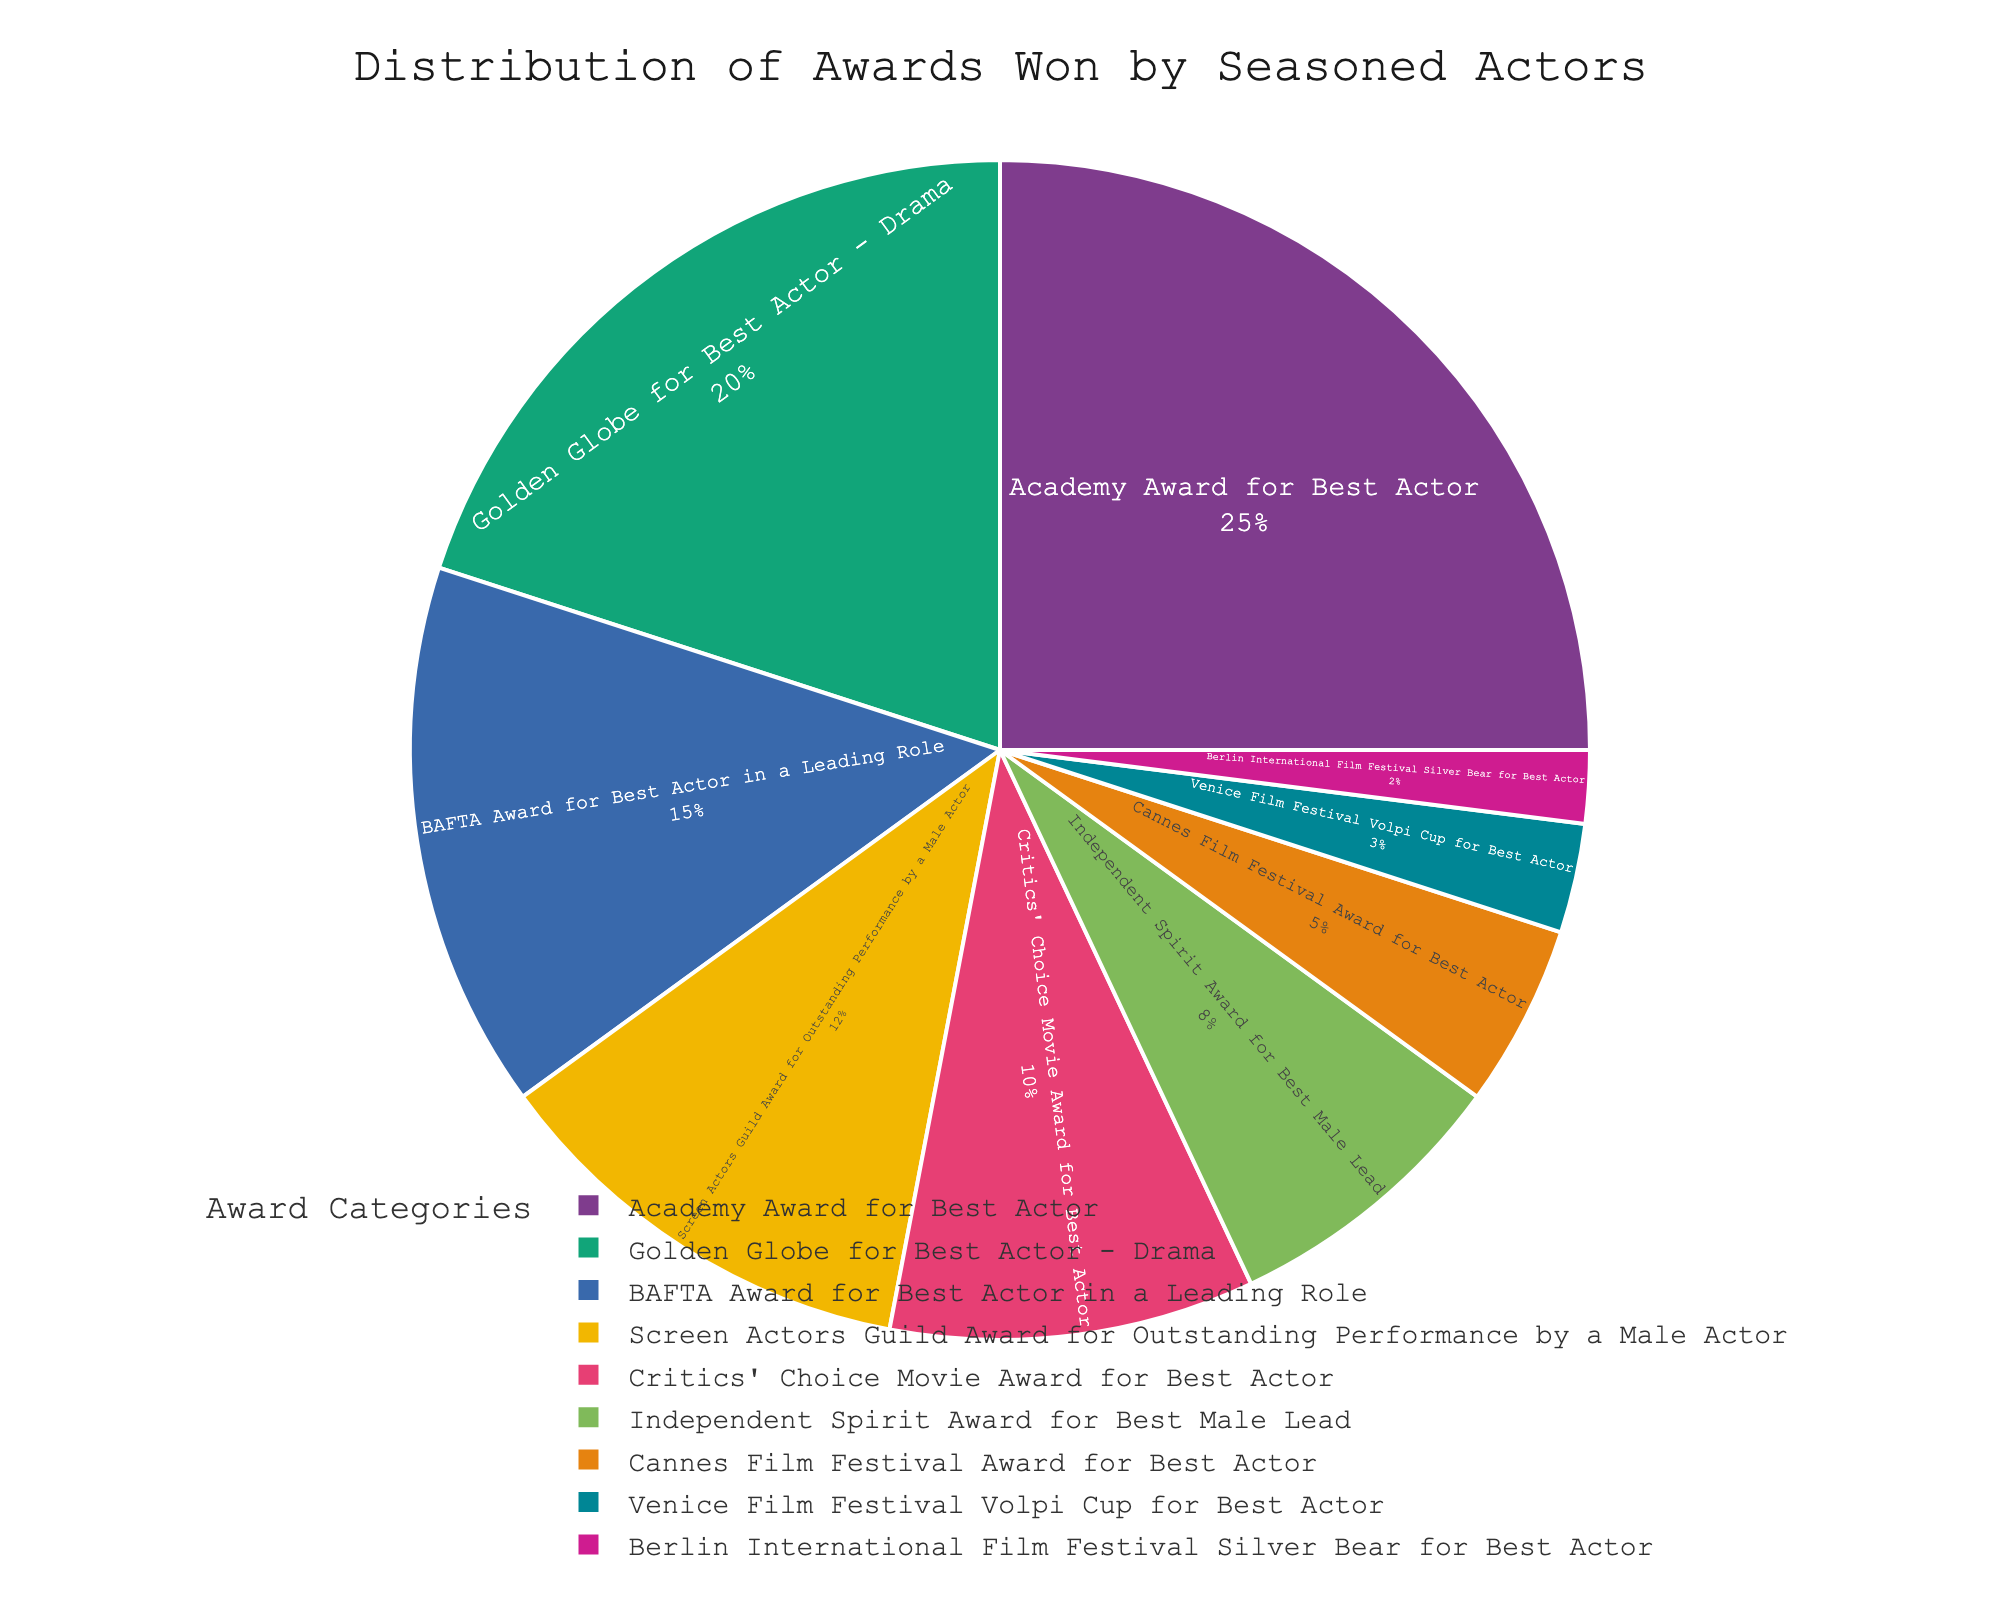What's the category with the highest percentage? The category with the highest percentage will have the largest slice in the pie chart. Observing the chart, we can see that the Academy Award for Best Actor has the largest slice.
Answer: Academy Award for Best Actor Which award has the smallest percentage? The category with the smallest percentage will have the smallest slice in the pie chart. Looking at the chart, the Berlin International Film Festival Silver Bear for Best Actor has the smallest slice.
Answer: Berlin International Film Festival Silver Bear for Best Actor What is the combined percentage of awards from Cannes Film Festival and Venice Film Festival? To find the combined percentage, sum the individual percentages of these categories. Cannes Film Festival Award for Best Actor has 5% and Venice Film Festival Volpi Cup for Best Actor has 3%. So, 5% + 3% = 8%.
Answer: 8% How much more is the percentage of Academy Awards compared to Critics' Choice Awards? To determine how much more the percentage is, subtract the Critics' Choice percentage from the Academy Award's percentage. Academy Award has 25% and Critics' Choice has 10%. So, 25% - 10% = 15%.
Answer: 15% What percentage of awards is represented by Golden Globe for Best Actor - Drama compared to BAFTA Award for Best Actor? Directly comparing the percentages, Golden Globe for Best Actor - Drama is 20% and BAFTA Award for Best Actor is 15%. So, the comparison is 20% to 15%.
Answer: Golden Globe for Best Actor - Drama: 20%, BAFTA Award for Best Actor: 15% Is the percentage of Screen Actors Guild Award more than that of the Independent Spirit Award? Compare the percentages of both categories. Screen Actors Guild Award has 12% and Independent Spirit Award has 8%. Since 12% is greater than 8%, the answer is yes.
Answer: Yes Calculate the total percentage of awards won by seasoned actors from Academy Awards, Golden Globes, and BAFTAs. To find the total percentage, sum the individual percentages of these categories. Academy Award has 25%, Golden Globe has 20%, and BAFTA Award has 15%. So, 25% + 20% + 15% = 60%.
Answer: 60% What is the difference between the percentages of awarded categories with the highest and lowest values? The highest percentage is for the Academy Award for Best Actor at 25%, and the lowest is for the Berlin International Film Festival Silver Bear for Best Actor at 2%. The difference is 25% - 2% = 23%.
Answer: 23% Which categories have a percentage below 10%? To find the categories with percentages below 10%, we look for slices of the pie chart that represent less than 10%. These categories are Independent Spirit Award for Best Male Lead (8%), Cannes Film Festival Award for Best Actor (5%), Venice Film Festival Volpi Cup for Best Actor (3%), and Berlin International Film Festival Silver Bear for Best Actor (2%).
Answer: Independent Spirit Award, Cannes Film Festival Award, Venice Film Festival Volpi Cup, Berlin International Film Festival Silver Bear If the BAFTA and Screen Actors Guild Awards were combined into one category, what would be their combined percentage? Sum the percentages of BAFTA Award for Best Actor in a Leading Role (15%) and Screen Actors Guild Award for Outstanding Performance by a Male Actor (12%). So, 15% + 12% = 27%.
Answer: 27% 